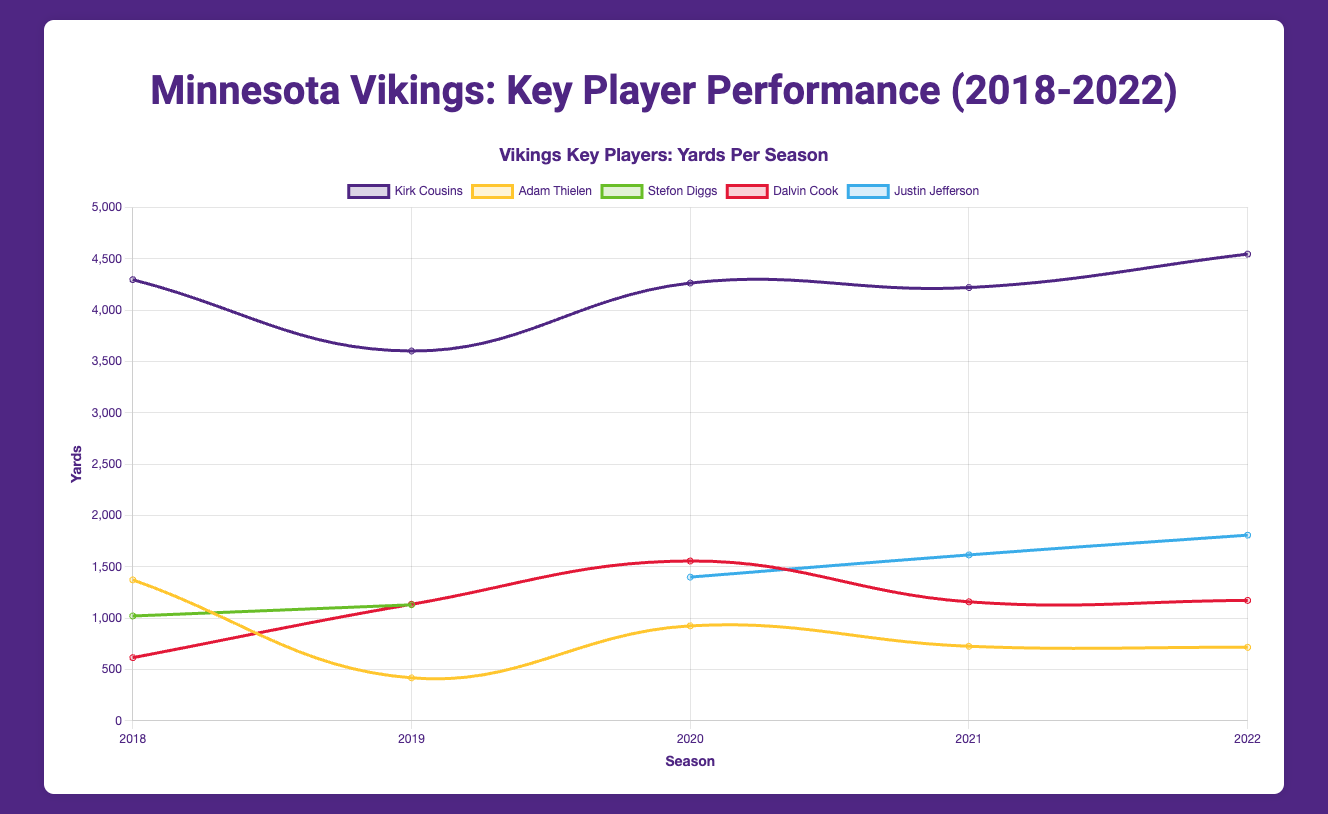Which player had the highest yards in the 2022 season? By looking at the figure, we can see that Justin Jefferson's line reaches the highest point in the 2022 season, indicating he had the most yards.
Answer: Justin Jefferson How did Adam Thielen's yards change from 2018 to 2019? In 2018, Adam Thielen had 1373 yards. In 2019, he had 418 yards. The difference is 1373 - 418.
Answer: A decrease of 955 yards Compare Kirk Cousins' touchdowns in 2018 and 2022. In 2018, Kirk Cousins scored 30 touchdowns. In 2022, he scored 29 touchdowns.
Answer: 1 touchdown less in 2022 What's the average number of yards gained by Dalvin Cook across all seasons? Dalvin Cook's yards per season: 615, 1135, 1557, 1159, 1173. Sum these to get 5639. Divide by the number of seasons (5) to get the average.
Answer: 1127.8 yards In which season did Justin Jefferson first appear and what were his yards that season? Justin Jefferson first appeared in 2020 with 1400 yards.
Answer: 2020, 1400 yards Which player showed the most improvement in touchdowns from the 2018 season to the 2020 season? Compare the change in touchdowns over these seasons for each player. Kirk Cousins: 30 to 35 (increase of 5), Adam Thielen: 9 to 14 (increase of 5), Stefon Diggs did not play both seasons, Dalvin Cook: 2 to 16 (increase of 14).
Answer: Dalvin Cook What's the total number of touchdowns scored by Adam Thielen from 2018 to 2022? Sum of Thielen's touchdowns: 9 (2018) + 6 (2019) + 14 (2020) + 10 (2021) + 6 (2022).
Answer: 45 touchdowns Compare the yards gained by Stefon Diggs in 2019 to Justin Jefferson in 2020. Stefon Diggs in 2019 had 1130 yards, whereas Justin Jefferson in 2020 had 1400 yards.
Answer: Justin Jefferson had 270 more yards In which seasons did Dalvin Cook score more than 1000 yards? Dalvin Cook scored the following yards: 615 (2018), 1135 (2019), 1557 (2020), 1159 (2021), 1173 (2022).
Answer: 2019, 2020, 2021, and 2022 How many interceptions did Kirk Cousins have in 2021, and how does this compare to his interceptions in 2022? Kirk Cousins had 7 interceptions in 2021 and 14 interceptions in 2022.
Answer: 7 more interceptions in 2022 